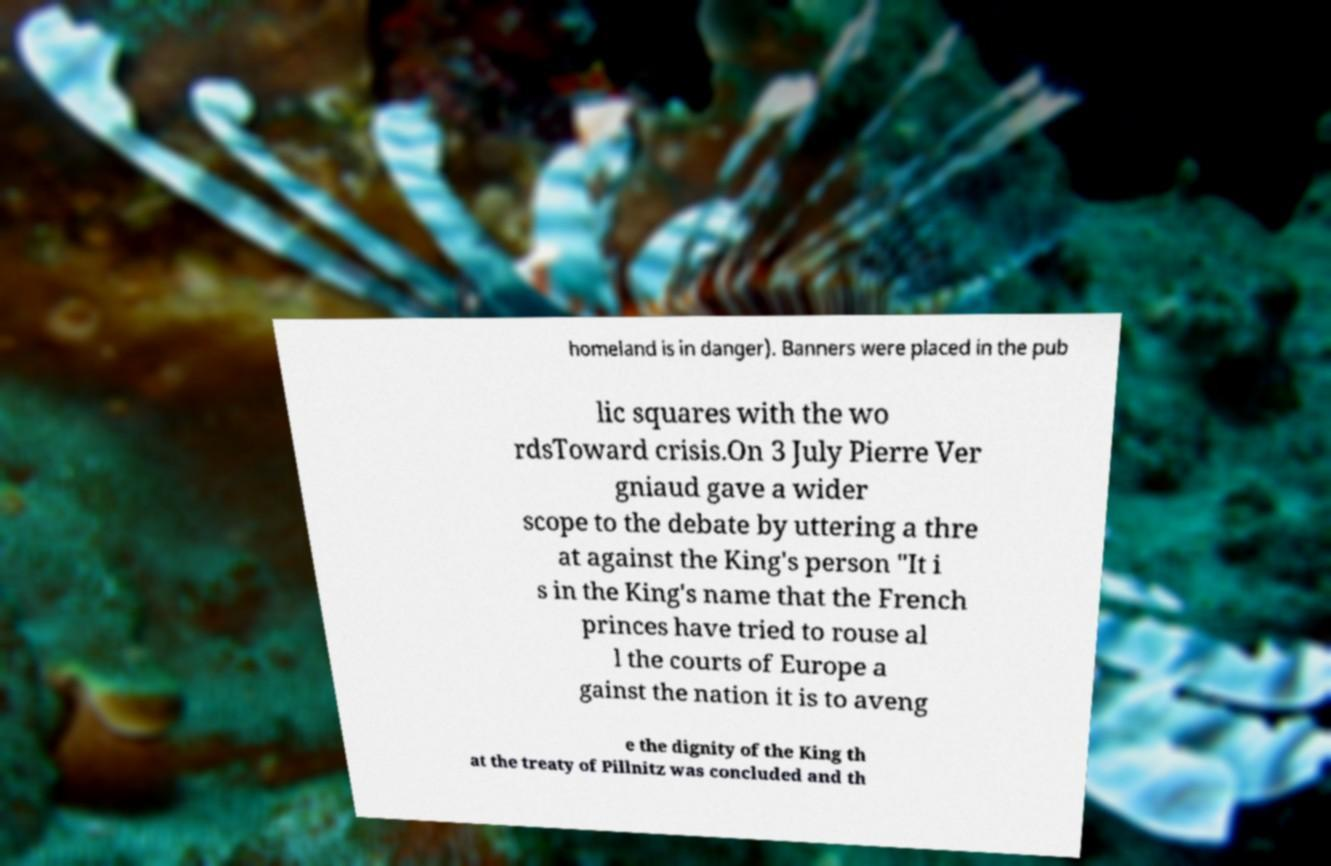Please read and relay the text visible in this image. What does it say? homeland is in danger). Banners were placed in the pub lic squares with the wo rdsToward crisis.On 3 July Pierre Ver gniaud gave a wider scope to the debate by uttering a thre at against the King's person "It i s in the King's name that the French princes have tried to rouse al l the courts of Europe a gainst the nation it is to aveng e the dignity of the King th at the treaty of Pillnitz was concluded and th 